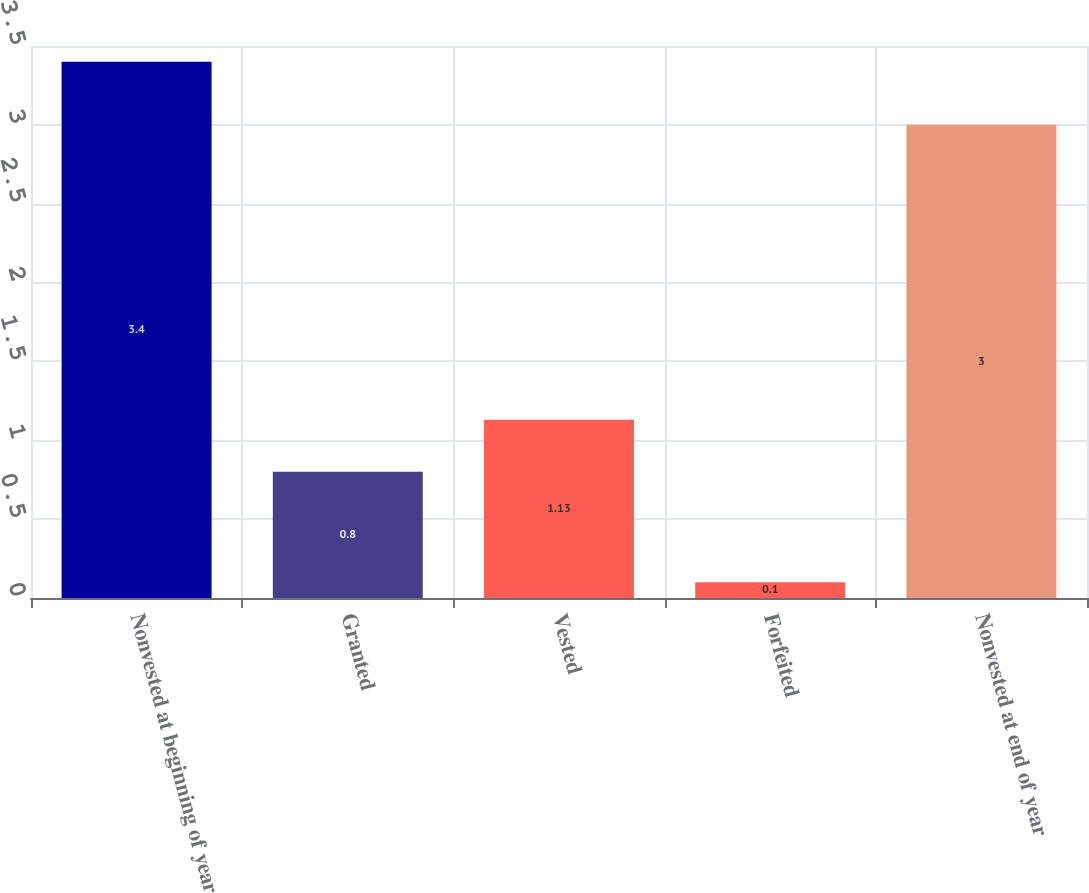Convert chart. <chart><loc_0><loc_0><loc_500><loc_500><bar_chart><fcel>Nonvested at beginning of year<fcel>Granted<fcel>Vested<fcel>Forfeited<fcel>Nonvested at end of year<nl><fcel>3.4<fcel>0.8<fcel>1.13<fcel>0.1<fcel>3<nl></chart> 